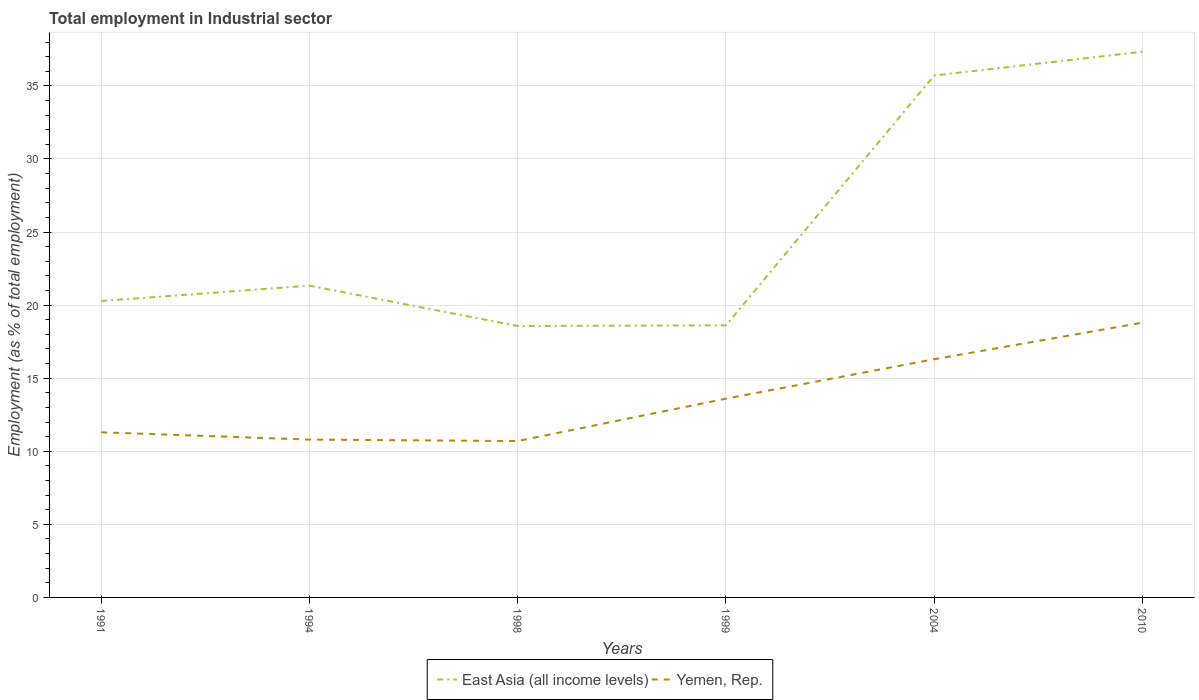How many different coloured lines are there?
Your response must be concise. 2. Is the number of lines equal to the number of legend labels?
Your answer should be compact. Yes. Across all years, what is the maximum employment in industrial sector in Yemen, Rep.?
Offer a terse response. 10.7. What is the total employment in industrial sector in Yemen, Rep. in the graph?
Your answer should be compact. -5.5. What is the difference between the highest and the second highest employment in industrial sector in East Asia (all income levels)?
Offer a very short reply. 18.77. What is the difference between the highest and the lowest employment in industrial sector in East Asia (all income levels)?
Your response must be concise. 2. How many lines are there?
Offer a very short reply. 2. Are the values on the major ticks of Y-axis written in scientific E-notation?
Provide a succinct answer. No. Does the graph contain grids?
Give a very brief answer. Yes. How many legend labels are there?
Provide a short and direct response. 2. How are the legend labels stacked?
Provide a succinct answer. Horizontal. What is the title of the graph?
Offer a terse response. Total employment in Industrial sector. Does "Bulgaria" appear as one of the legend labels in the graph?
Provide a succinct answer. No. What is the label or title of the Y-axis?
Your response must be concise. Employment (as % of total employment). What is the Employment (as % of total employment) of East Asia (all income levels) in 1991?
Keep it short and to the point. 20.28. What is the Employment (as % of total employment) in Yemen, Rep. in 1991?
Offer a very short reply. 11.3. What is the Employment (as % of total employment) in East Asia (all income levels) in 1994?
Ensure brevity in your answer.  21.33. What is the Employment (as % of total employment) of Yemen, Rep. in 1994?
Keep it short and to the point. 10.8. What is the Employment (as % of total employment) in East Asia (all income levels) in 1998?
Provide a short and direct response. 18.57. What is the Employment (as % of total employment) in Yemen, Rep. in 1998?
Keep it short and to the point. 10.7. What is the Employment (as % of total employment) in East Asia (all income levels) in 1999?
Keep it short and to the point. 18.62. What is the Employment (as % of total employment) in Yemen, Rep. in 1999?
Make the answer very short. 13.6. What is the Employment (as % of total employment) of East Asia (all income levels) in 2004?
Your response must be concise. 35.71. What is the Employment (as % of total employment) in Yemen, Rep. in 2004?
Offer a terse response. 16.3. What is the Employment (as % of total employment) in East Asia (all income levels) in 2010?
Keep it short and to the point. 37.34. What is the Employment (as % of total employment) of Yemen, Rep. in 2010?
Give a very brief answer. 18.8. Across all years, what is the maximum Employment (as % of total employment) of East Asia (all income levels)?
Ensure brevity in your answer.  37.34. Across all years, what is the maximum Employment (as % of total employment) in Yemen, Rep.?
Your answer should be compact. 18.8. Across all years, what is the minimum Employment (as % of total employment) of East Asia (all income levels)?
Your answer should be compact. 18.57. Across all years, what is the minimum Employment (as % of total employment) in Yemen, Rep.?
Provide a succinct answer. 10.7. What is the total Employment (as % of total employment) in East Asia (all income levels) in the graph?
Provide a succinct answer. 151.86. What is the total Employment (as % of total employment) of Yemen, Rep. in the graph?
Give a very brief answer. 81.5. What is the difference between the Employment (as % of total employment) in East Asia (all income levels) in 1991 and that in 1994?
Make the answer very short. -1.05. What is the difference between the Employment (as % of total employment) in East Asia (all income levels) in 1991 and that in 1998?
Your response must be concise. 1.71. What is the difference between the Employment (as % of total employment) in Yemen, Rep. in 1991 and that in 1998?
Offer a terse response. 0.6. What is the difference between the Employment (as % of total employment) in East Asia (all income levels) in 1991 and that in 1999?
Offer a terse response. 1.66. What is the difference between the Employment (as % of total employment) of East Asia (all income levels) in 1991 and that in 2004?
Your answer should be compact. -15.43. What is the difference between the Employment (as % of total employment) in East Asia (all income levels) in 1991 and that in 2010?
Give a very brief answer. -17.06. What is the difference between the Employment (as % of total employment) in East Asia (all income levels) in 1994 and that in 1998?
Your answer should be compact. 2.76. What is the difference between the Employment (as % of total employment) of East Asia (all income levels) in 1994 and that in 1999?
Provide a succinct answer. 2.71. What is the difference between the Employment (as % of total employment) of Yemen, Rep. in 1994 and that in 1999?
Offer a terse response. -2.8. What is the difference between the Employment (as % of total employment) in East Asia (all income levels) in 1994 and that in 2004?
Offer a terse response. -14.38. What is the difference between the Employment (as % of total employment) in East Asia (all income levels) in 1994 and that in 2010?
Keep it short and to the point. -16.01. What is the difference between the Employment (as % of total employment) in East Asia (all income levels) in 1998 and that in 1999?
Your response must be concise. -0.05. What is the difference between the Employment (as % of total employment) in East Asia (all income levels) in 1998 and that in 2004?
Make the answer very short. -17.14. What is the difference between the Employment (as % of total employment) of East Asia (all income levels) in 1998 and that in 2010?
Offer a terse response. -18.77. What is the difference between the Employment (as % of total employment) in East Asia (all income levels) in 1999 and that in 2004?
Provide a succinct answer. -17.09. What is the difference between the Employment (as % of total employment) of Yemen, Rep. in 1999 and that in 2004?
Keep it short and to the point. -2.7. What is the difference between the Employment (as % of total employment) in East Asia (all income levels) in 1999 and that in 2010?
Your answer should be very brief. -18.72. What is the difference between the Employment (as % of total employment) of East Asia (all income levels) in 2004 and that in 2010?
Offer a very short reply. -1.63. What is the difference between the Employment (as % of total employment) of Yemen, Rep. in 2004 and that in 2010?
Make the answer very short. -2.5. What is the difference between the Employment (as % of total employment) in East Asia (all income levels) in 1991 and the Employment (as % of total employment) in Yemen, Rep. in 1994?
Offer a terse response. 9.48. What is the difference between the Employment (as % of total employment) in East Asia (all income levels) in 1991 and the Employment (as % of total employment) in Yemen, Rep. in 1998?
Provide a succinct answer. 9.58. What is the difference between the Employment (as % of total employment) of East Asia (all income levels) in 1991 and the Employment (as % of total employment) of Yemen, Rep. in 1999?
Ensure brevity in your answer.  6.68. What is the difference between the Employment (as % of total employment) in East Asia (all income levels) in 1991 and the Employment (as % of total employment) in Yemen, Rep. in 2004?
Your answer should be compact. 3.98. What is the difference between the Employment (as % of total employment) in East Asia (all income levels) in 1991 and the Employment (as % of total employment) in Yemen, Rep. in 2010?
Keep it short and to the point. 1.48. What is the difference between the Employment (as % of total employment) of East Asia (all income levels) in 1994 and the Employment (as % of total employment) of Yemen, Rep. in 1998?
Ensure brevity in your answer.  10.63. What is the difference between the Employment (as % of total employment) in East Asia (all income levels) in 1994 and the Employment (as % of total employment) in Yemen, Rep. in 1999?
Give a very brief answer. 7.73. What is the difference between the Employment (as % of total employment) of East Asia (all income levels) in 1994 and the Employment (as % of total employment) of Yemen, Rep. in 2004?
Give a very brief answer. 5.03. What is the difference between the Employment (as % of total employment) of East Asia (all income levels) in 1994 and the Employment (as % of total employment) of Yemen, Rep. in 2010?
Offer a terse response. 2.53. What is the difference between the Employment (as % of total employment) in East Asia (all income levels) in 1998 and the Employment (as % of total employment) in Yemen, Rep. in 1999?
Your answer should be very brief. 4.97. What is the difference between the Employment (as % of total employment) in East Asia (all income levels) in 1998 and the Employment (as % of total employment) in Yemen, Rep. in 2004?
Ensure brevity in your answer.  2.27. What is the difference between the Employment (as % of total employment) in East Asia (all income levels) in 1998 and the Employment (as % of total employment) in Yemen, Rep. in 2010?
Your answer should be very brief. -0.23. What is the difference between the Employment (as % of total employment) of East Asia (all income levels) in 1999 and the Employment (as % of total employment) of Yemen, Rep. in 2004?
Your response must be concise. 2.32. What is the difference between the Employment (as % of total employment) in East Asia (all income levels) in 1999 and the Employment (as % of total employment) in Yemen, Rep. in 2010?
Offer a terse response. -0.18. What is the difference between the Employment (as % of total employment) of East Asia (all income levels) in 2004 and the Employment (as % of total employment) of Yemen, Rep. in 2010?
Offer a terse response. 16.91. What is the average Employment (as % of total employment) in East Asia (all income levels) per year?
Offer a very short reply. 25.31. What is the average Employment (as % of total employment) of Yemen, Rep. per year?
Provide a short and direct response. 13.58. In the year 1991, what is the difference between the Employment (as % of total employment) in East Asia (all income levels) and Employment (as % of total employment) in Yemen, Rep.?
Keep it short and to the point. 8.98. In the year 1994, what is the difference between the Employment (as % of total employment) of East Asia (all income levels) and Employment (as % of total employment) of Yemen, Rep.?
Offer a very short reply. 10.53. In the year 1998, what is the difference between the Employment (as % of total employment) of East Asia (all income levels) and Employment (as % of total employment) of Yemen, Rep.?
Ensure brevity in your answer.  7.87. In the year 1999, what is the difference between the Employment (as % of total employment) in East Asia (all income levels) and Employment (as % of total employment) in Yemen, Rep.?
Give a very brief answer. 5.02. In the year 2004, what is the difference between the Employment (as % of total employment) of East Asia (all income levels) and Employment (as % of total employment) of Yemen, Rep.?
Make the answer very short. 19.41. In the year 2010, what is the difference between the Employment (as % of total employment) in East Asia (all income levels) and Employment (as % of total employment) in Yemen, Rep.?
Your answer should be compact. 18.54. What is the ratio of the Employment (as % of total employment) of East Asia (all income levels) in 1991 to that in 1994?
Offer a terse response. 0.95. What is the ratio of the Employment (as % of total employment) of Yemen, Rep. in 1991 to that in 1994?
Ensure brevity in your answer.  1.05. What is the ratio of the Employment (as % of total employment) in East Asia (all income levels) in 1991 to that in 1998?
Provide a succinct answer. 1.09. What is the ratio of the Employment (as % of total employment) of Yemen, Rep. in 1991 to that in 1998?
Keep it short and to the point. 1.06. What is the ratio of the Employment (as % of total employment) in East Asia (all income levels) in 1991 to that in 1999?
Provide a short and direct response. 1.09. What is the ratio of the Employment (as % of total employment) in Yemen, Rep. in 1991 to that in 1999?
Your answer should be compact. 0.83. What is the ratio of the Employment (as % of total employment) in East Asia (all income levels) in 1991 to that in 2004?
Make the answer very short. 0.57. What is the ratio of the Employment (as % of total employment) in Yemen, Rep. in 1991 to that in 2004?
Give a very brief answer. 0.69. What is the ratio of the Employment (as % of total employment) of East Asia (all income levels) in 1991 to that in 2010?
Provide a succinct answer. 0.54. What is the ratio of the Employment (as % of total employment) in Yemen, Rep. in 1991 to that in 2010?
Keep it short and to the point. 0.6. What is the ratio of the Employment (as % of total employment) of East Asia (all income levels) in 1994 to that in 1998?
Ensure brevity in your answer.  1.15. What is the ratio of the Employment (as % of total employment) of Yemen, Rep. in 1994 to that in 1998?
Provide a short and direct response. 1.01. What is the ratio of the Employment (as % of total employment) in East Asia (all income levels) in 1994 to that in 1999?
Provide a short and direct response. 1.15. What is the ratio of the Employment (as % of total employment) in Yemen, Rep. in 1994 to that in 1999?
Your answer should be compact. 0.79. What is the ratio of the Employment (as % of total employment) of East Asia (all income levels) in 1994 to that in 2004?
Offer a very short reply. 0.6. What is the ratio of the Employment (as % of total employment) of Yemen, Rep. in 1994 to that in 2004?
Provide a succinct answer. 0.66. What is the ratio of the Employment (as % of total employment) in East Asia (all income levels) in 1994 to that in 2010?
Offer a terse response. 0.57. What is the ratio of the Employment (as % of total employment) in Yemen, Rep. in 1994 to that in 2010?
Your answer should be compact. 0.57. What is the ratio of the Employment (as % of total employment) in East Asia (all income levels) in 1998 to that in 1999?
Give a very brief answer. 1. What is the ratio of the Employment (as % of total employment) in Yemen, Rep. in 1998 to that in 1999?
Ensure brevity in your answer.  0.79. What is the ratio of the Employment (as % of total employment) of East Asia (all income levels) in 1998 to that in 2004?
Provide a short and direct response. 0.52. What is the ratio of the Employment (as % of total employment) in Yemen, Rep. in 1998 to that in 2004?
Keep it short and to the point. 0.66. What is the ratio of the Employment (as % of total employment) of East Asia (all income levels) in 1998 to that in 2010?
Ensure brevity in your answer.  0.5. What is the ratio of the Employment (as % of total employment) of Yemen, Rep. in 1998 to that in 2010?
Ensure brevity in your answer.  0.57. What is the ratio of the Employment (as % of total employment) of East Asia (all income levels) in 1999 to that in 2004?
Provide a succinct answer. 0.52. What is the ratio of the Employment (as % of total employment) in Yemen, Rep. in 1999 to that in 2004?
Offer a terse response. 0.83. What is the ratio of the Employment (as % of total employment) in East Asia (all income levels) in 1999 to that in 2010?
Keep it short and to the point. 0.5. What is the ratio of the Employment (as % of total employment) in Yemen, Rep. in 1999 to that in 2010?
Make the answer very short. 0.72. What is the ratio of the Employment (as % of total employment) of East Asia (all income levels) in 2004 to that in 2010?
Your answer should be compact. 0.96. What is the ratio of the Employment (as % of total employment) in Yemen, Rep. in 2004 to that in 2010?
Make the answer very short. 0.87. What is the difference between the highest and the second highest Employment (as % of total employment) in East Asia (all income levels)?
Ensure brevity in your answer.  1.63. What is the difference between the highest and the lowest Employment (as % of total employment) of East Asia (all income levels)?
Offer a terse response. 18.77. What is the difference between the highest and the lowest Employment (as % of total employment) in Yemen, Rep.?
Keep it short and to the point. 8.1. 